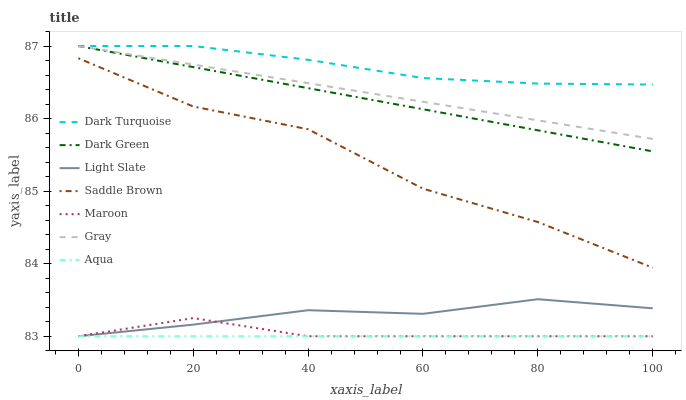Does Aqua have the minimum area under the curve?
Answer yes or no. Yes. Does Dark Turquoise have the maximum area under the curve?
Answer yes or no. Yes. Does Light Slate have the minimum area under the curve?
Answer yes or no. No. Does Light Slate have the maximum area under the curve?
Answer yes or no. No. Is Aqua the smoothest?
Answer yes or no. Yes. Is Saddle Brown the roughest?
Answer yes or no. Yes. Is Light Slate the smoothest?
Answer yes or no. No. Is Light Slate the roughest?
Answer yes or no. No. Does Light Slate have the lowest value?
Answer yes or no. Yes. Does Dark Turquoise have the lowest value?
Answer yes or no. No. Does Dark Green have the highest value?
Answer yes or no. Yes. Does Light Slate have the highest value?
Answer yes or no. No. Is Maroon less than Gray?
Answer yes or no. Yes. Is Dark Green greater than Maroon?
Answer yes or no. Yes. Does Gray intersect Dark Green?
Answer yes or no. Yes. Is Gray less than Dark Green?
Answer yes or no. No. Is Gray greater than Dark Green?
Answer yes or no. No. Does Maroon intersect Gray?
Answer yes or no. No. 